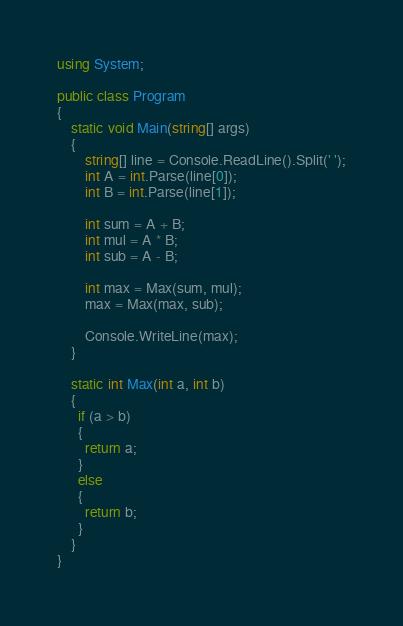<code> <loc_0><loc_0><loc_500><loc_500><_C#_>using System;

public class Program
{
	static void Main(string[] args)
	{
		string[] line = Console.ReadLine().Split(' ');
		int A = int.Parse(line[0]);
		int B = int.Parse(line[1]);

		int sum = A + B;
		int mul = A * B;
		int sub = A - B;

      	int max = Max(sum, mul);
		max = Max(max, sub);

		Console.WriteLine(max);      	
	}
  
    static int Max(int a, int b)
    {
      if (a > b)
      {
        return a;
      }
      else
      {
        return b;
      }
    }
}
</code> 